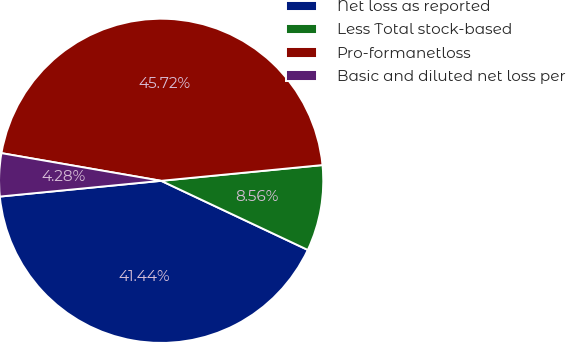Convert chart to OTSL. <chart><loc_0><loc_0><loc_500><loc_500><pie_chart><fcel>Net loss as reported<fcel>Less Total stock-based<fcel>Pro-formanetloss<fcel>Basic and diluted net loss per<nl><fcel>41.44%<fcel>8.56%<fcel>45.72%<fcel>4.28%<nl></chart> 